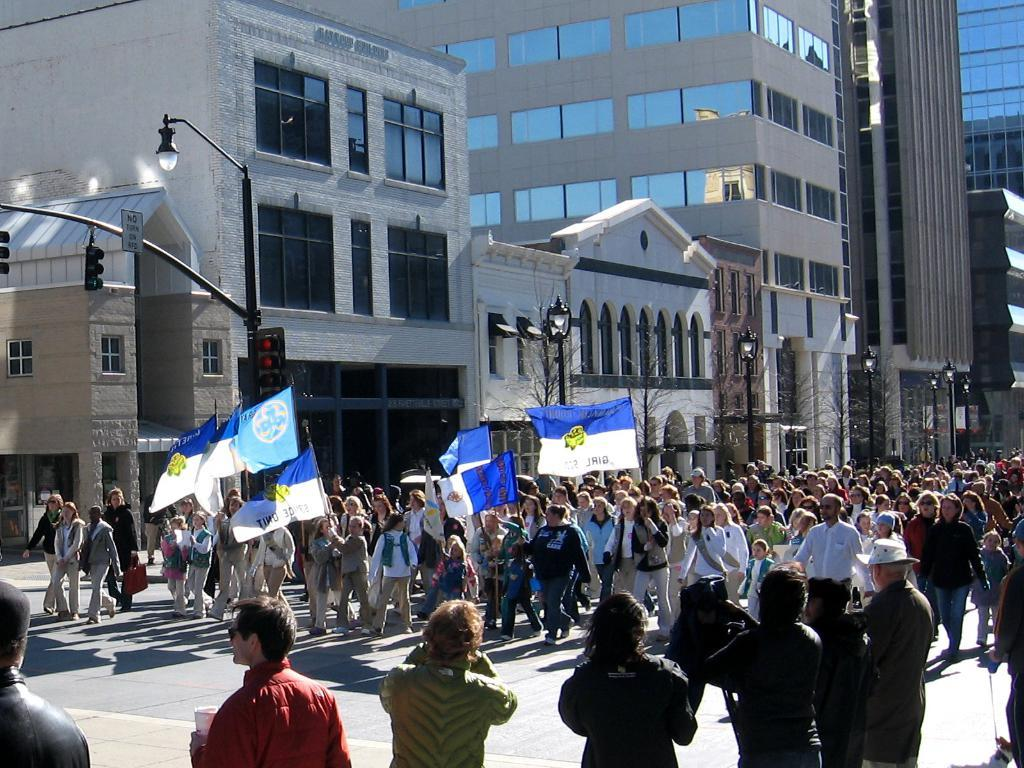What is happening with the group of people in the image? The people are walking on the road in the image. What are the people holding while walking? The people are holding flags while walking. What can be seen in the background of the image? In the background of the image, there are lights, poles, buildings, and trees. What type of maid is working in the kitchen in the image? There is no maid or kitchen present in the image; it features a group of people walking on the road while holding flags. What title is given to the stove in the image? There is no stove present in the image. 